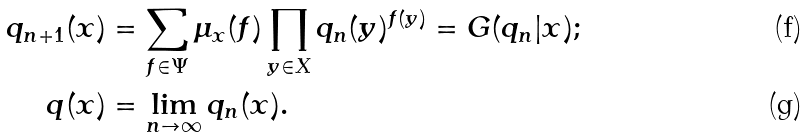<formula> <loc_0><loc_0><loc_500><loc_500>q _ { n + 1 } ( x ) & = \sum _ { f \in \Psi } \mu _ { x } ( f ) \prod _ { y \in X } q _ { n } ( y ) ^ { f ( y ) } = G ( q _ { n } | x ) ; \\ q ( x ) & = \lim _ { n \to \infty } q _ { n } ( x ) .</formula> 